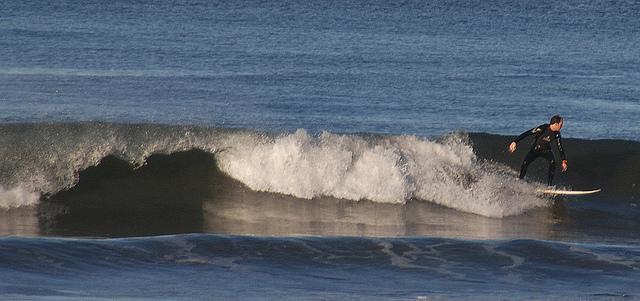How many pizzas are there?
Give a very brief answer. 0. 